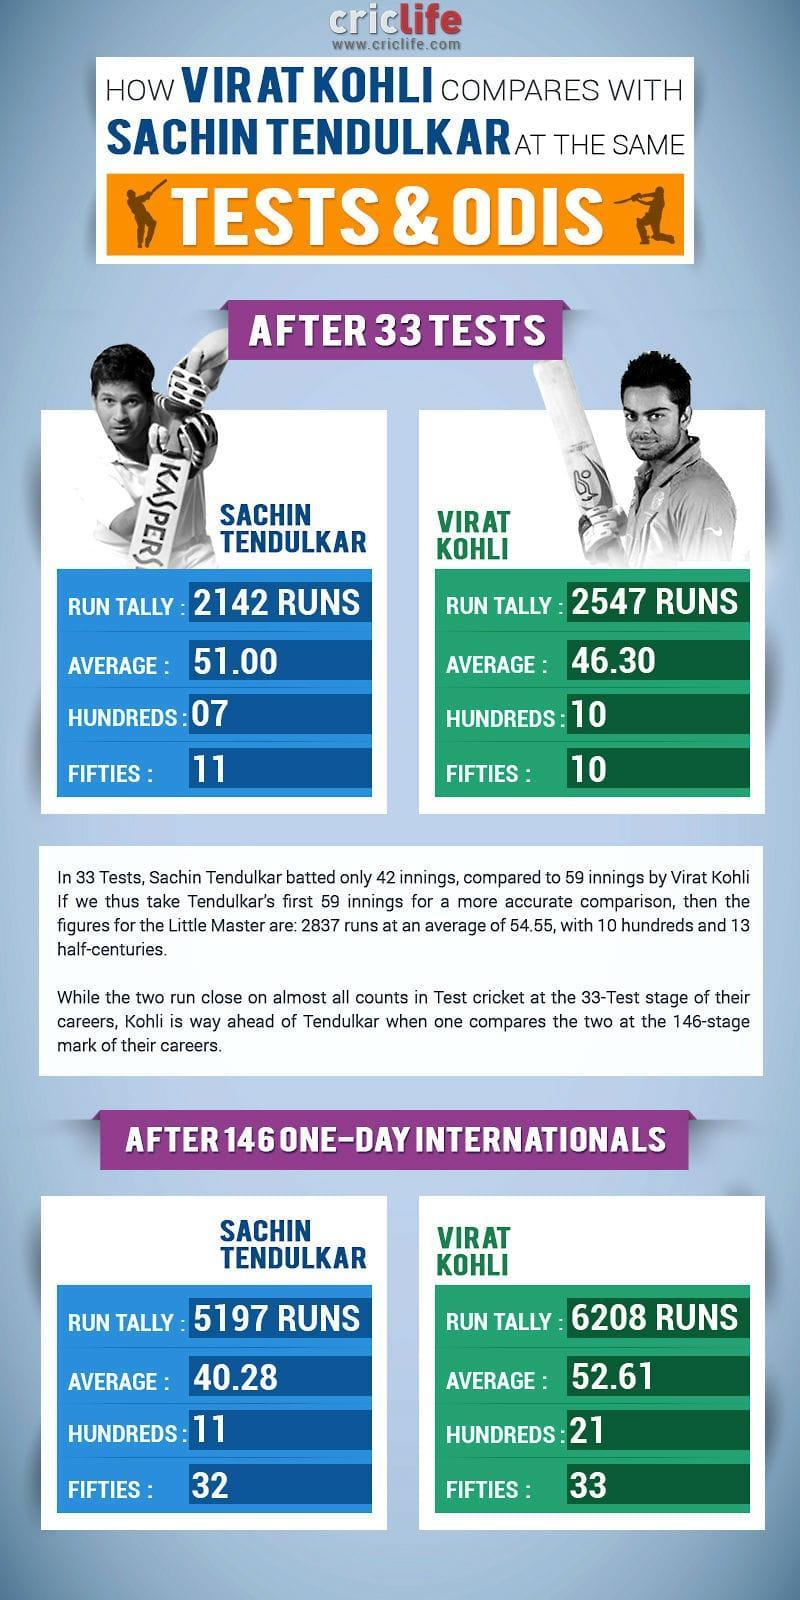How many hundreds scored by Sachin and Kohli together after 33 tests?
Answer the question with a short phrase. 17 How many hundreds scored by Sachin and Kohli together after 146 one-day international? 32 How many fifties scored by Sachin and Kohli together after 33 tests? 21 How many fifties scored by Sachin and Kohli together after 146 one-day international? 65 